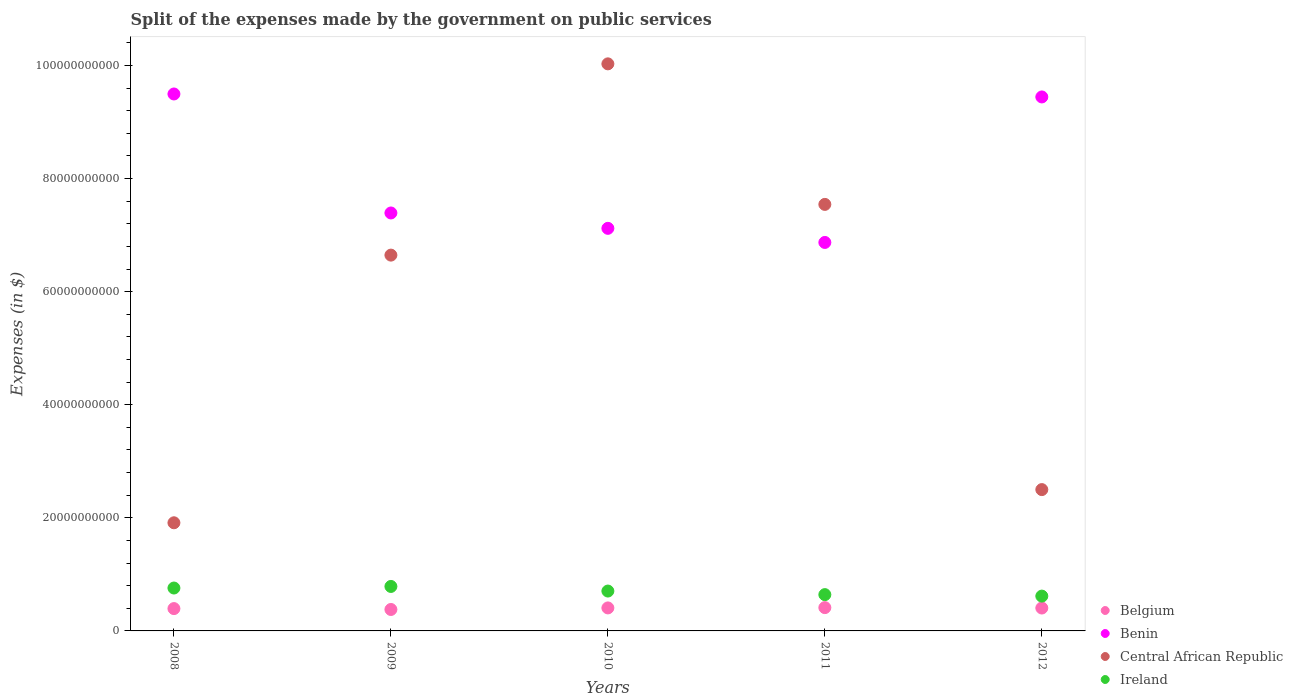Is the number of dotlines equal to the number of legend labels?
Provide a succinct answer. Yes. What is the expenses made by the government on public services in Central African Republic in 2011?
Offer a very short reply. 7.54e+1. Across all years, what is the maximum expenses made by the government on public services in Ireland?
Ensure brevity in your answer.  7.87e+09. Across all years, what is the minimum expenses made by the government on public services in Belgium?
Offer a very short reply. 3.79e+09. What is the total expenses made by the government on public services in Belgium in the graph?
Provide a succinct answer. 2.00e+1. What is the difference between the expenses made by the government on public services in Benin in 2009 and that in 2012?
Provide a short and direct response. -2.05e+1. What is the difference between the expenses made by the government on public services in Ireland in 2008 and the expenses made by the government on public services in Benin in 2010?
Make the answer very short. -6.36e+1. What is the average expenses made by the government on public services in Central African Republic per year?
Offer a very short reply. 5.73e+1. In the year 2011, what is the difference between the expenses made by the government on public services in Belgium and expenses made by the government on public services in Central African Republic?
Your answer should be compact. -7.13e+1. What is the ratio of the expenses made by the government on public services in Ireland in 2011 to that in 2012?
Ensure brevity in your answer.  1.04. Is the expenses made by the government on public services in Central African Republic in 2010 less than that in 2012?
Offer a terse response. No. What is the difference between the highest and the second highest expenses made by the government on public services in Ireland?
Provide a short and direct response. 2.79e+08. What is the difference between the highest and the lowest expenses made by the government on public services in Ireland?
Keep it short and to the point. 1.71e+09. In how many years, is the expenses made by the government on public services in Belgium greater than the average expenses made by the government on public services in Belgium taken over all years?
Ensure brevity in your answer.  3. Is the sum of the expenses made by the government on public services in Ireland in 2008 and 2011 greater than the maximum expenses made by the government on public services in Benin across all years?
Make the answer very short. No. Is it the case that in every year, the sum of the expenses made by the government on public services in Ireland and expenses made by the government on public services in Belgium  is greater than the sum of expenses made by the government on public services in Benin and expenses made by the government on public services in Central African Republic?
Give a very brief answer. No. Is it the case that in every year, the sum of the expenses made by the government on public services in Benin and expenses made by the government on public services in Ireland  is greater than the expenses made by the government on public services in Belgium?
Provide a short and direct response. Yes. How many dotlines are there?
Offer a very short reply. 4. What is the difference between two consecutive major ticks on the Y-axis?
Give a very brief answer. 2.00e+1. Are the values on the major ticks of Y-axis written in scientific E-notation?
Offer a very short reply. No. Does the graph contain grids?
Offer a very short reply. No. Where does the legend appear in the graph?
Keep it short and to the point. Bottom right. What is the title of the graph?
Offer a very short reply. Split of the expenses made by the government on public services. What is the label or title of the Y-axis?
Your response must be concise. Expenses (in $). What is the Expenses (in $) in Belgium in 2008?
Ensure brevity in your answer.  3.95e+09. What is the Expenses (in $) in Benin in 2008?
Offer a very short reply. 9.50e+1. What is the Expenses (in $) in Central African Republic in 2008?
Offer a very short reply. 1.91e+1. What is the Expenses (in $) of Ireland in 2008?
Your answer should be compact. 7.59e+09. What is the Expenses (in $) in Belgium in 2009?
Provide a succinct answer. 3.79e+09. What is the Expenses (in $) of Benin in 2009?
Ensure brevity in your answer.  7.39e+1. What is the Expenses (in $) in Central African Republic in 2009?
Provide a short and direct response. 6.65e+1. What is the Expenses (in $) of Ireland in 2009?
Ensure brevity in your answer.  7.87e+09. What is the Expenses (in $) of Belgium in 2010?
Your answer should be very brief. 4.07e+09. What is the Expenses (in $) of Benin in 2010?
Your response must be concise. 7.12e+1. What is the Expenses (in $) of Central African Republic in 2010?
Provide a short and direct response. 1.00e+11. What is the Expenses (in $) in Ireland in 2010?
Offer a terse response. 7.05e+09. What is the Expenses (in $) in Belgium in 2011?
Keep it short and to the point. 4.12e+09. What is the Expenses (in $) of Benin in 2011?
Ensure brevity in your answer.  6.87e+1. What is the Expenses (in $) in Central African Republic in 2011?
Your answer should be compact. 7.54e+1. What is the Expenses (in $) in Ireland in 2011?
Your answer should be very brief. 6.42e+09. What is the Expenses (in $) in Belgium in 2012?
Offer a very short reply. 4.05e+09. What is the Expenses (in $) of Benin in 2012?
Keep it short and to the point. 9.44e+1. What is the Expenses (in $) of Central African Republic in 2012?
Your answer should be very brief. 2.50e+1. What is the Expenses (in $) in Ireland in 2012?
Offer a very short reply. 6.16e+09. Across all years, what is the maximum Expenses (in $) in Belgium?
Provide a succinct answer. 4.12e+09. Across all years, what is the maximum Expenses (in $) of Benin?
Provide a short and direct response. 9.50e+1. Across all years, what is the maximum Expenses (in $) of Central African Republic?
Ensure brevity in your answer.  1.00e+11. Across all years, what is the maximum Expenses (in $) in Ireland?
Provide a succinct answer. 7.87e+09. Across all years, what is the minimum Expenses (in $) of Belgium?
Offer a terse response. 3.79e+09. Across all years, what is the minimum Expenses (in $) in Benin?
Your answer should be compact. 6.87e+1. Across all years, what is the minimum Expenses (in $) in Central African Republic?
Your response must be concise. 1.91e+1. Across all years, what is the minimum Expenses (in $) in Ireland?
Your answer should be compact. 6.16e+09. What is the total Expenses (in $) in Belgium in the graph?
Offer a very short reply. 2.00e+1. What is the total Expenses (in $) in Benin in the graph?
Offer a terse response. 4.03e+11. What is the total Expenses (in $) of Central African Republic in the graph?
Provide a succinct answer. 2.86e+11. What is the total Expenses (in $) in Ireland in the graph?
Offer a very short reply. 3.51e+1. What is the difference between the Expenses (in $) in Belgium in 2008 and that in 2009?
Provide a succinct answer. 1.58e+08. What is the difference between the Expenses (in $) of Benin in 2008 and that in 2009?
Provide a short and direct response. 2.10e+1. What is the difference between the Expenses (in $) in Central African Republic in 2008 and that in 2009?
Give a very brief answer. -4.73e+1. What is the difference between the Expenses (in $) of Ireland in 2008 and that in 2009?
Ensure brevity in your answer.  -2.79e+08. What is the difference between the Expenses (in $) in Belgium in 2008 and that in 2010?
Provide a short and direct response. -1.18e+08. What is the difference between the Expenses (in $) in Benin in 2008 and that in 2010?
Your answer should be compact. 2.38e+1. What is the difference between the Expenses (in $) in Central African Republic in 2008 and that in 2010?
Provide a short and direct response. -8.12e+1. What is the difference between the Expenses (in $) in Ireland in 2008 and that in 2010?
Ensure brevity in your answer.  5.35e+08. What is the difference between the Expenses (in $) of Belgium in 2008 and that in 2011?
Your answer should be compact. -1.72e+08. What is the difference between the Expenses (in $) of Benin in 2008 and that in 2011?
Ensure brevity in your answer.  2.63e+1. What is the difference between the Expenses (in $) of Central African Republic in 2008 and that in 2011?
Provide a short and direct response. -5.63e+1. What is the difference between the Expenses (in $) of Ireland in 2008 and that in 2011?
Ensure brevity in your answer.  1.17e+09. What is the difference between the Expenses (in $) in Belgium in 2008 and that in 2012?
Your answer should be compact. -9.98e+07. What is the difference between the Expenses (in $) of Benin in 2008 and that in 2012?
Offer a very short reply. 5.24e+08. What is the difference between the Expenses (in $) of Central African Republic in 2008 and that in 2012?
Offer a very short reply. -5.87e+09. What is the difference between the Expenses (in $) in Ireland in 2008 and that in 2012?
Offer a terse response. 1.43e+09. What is the difference between the Expenses (in $) of Belgium in 2009 and that in 2010?
Your answer should be very brief. -2.76e+08. What is the difference between the Expenses (in $) in Benin in 2009 and that in 2010?
Offer a very short reply. 2.72e+09. What is the difference between the Expenses (in $) of Central African Republic in 2009 and that in 2010?
Your answer should be very brief. -3.38e+1. What is the difference between the Expenses (in $) in Ireland in 2009 and that in 2010?
Provide a short and direct response. 8.15e+08. What is the difference between the Expenses (in $) in Belgium in 2009 and that in 2011?
Provide a succinct answer. -3.30e+08. What is the difference between the Expenses (in $) in Benin in 2009 and that in 2011?
Provide a succinct answer. 5.21e+09. What is the difference between the Expenses (in $) in Central African Republic in 2009 and that in 2011?
Offer a very short reply. -8.97e+09. What is the difference between the Expenses (in $) in Ireland in 2009 and that in 2011?
Make the answer very short. 1.45e+09. What is the difference between the Expenses (in $) in Belgium in 2009 and that in 2012?
Give a very brief answer. -2.58e+08. What is the difference between the Expenses (in $) of Benin in 2009 and that in 2012?
Make the answer very short. -2.05e+1. What is the difference between the Expenses (in $) of Central African Republic in 2009 and that in 2012?
Give a very brief answer. 4.15e+1. What is the difference between the Expenses (in $) of Ireland in 2009 and that in 2012?
Provide a succinct answer. 1.71e+09. What is the difference between the Expenses (in $) of Belgium in 2010 and that in 2011?
Provide a short and direct response. -5.37e+07. What is the difference between the Expenses (in $) of Benin in 2010 and that in 2011?
Your response must be concise. 2.49e+09. What is the difference between the Expenses (in $) of Central African Republic in 2010 and that in 2011?
Your answer should be compact. 2.49e+1. What is the difference between the Expenses (in $) of Ireland in 2010 and that in 2011?
Give a very brief answer. 6.31e+08. What is the difference between the Expenses (in $) of Belgium in 2010 and that in 2012?
Ensure brevity in your answer.  1.86e+07. What is the difference between the Expenses (in $) in Benin in 2010 and that in 2012?
Provide a short and direct response. -2.32e+1. What is the difference between the Expenses (in $) of Central African Republic in 2010 and that in 2012?
Offer a very short reply. 7.53e+1. What is the difference between the Expenses (in $) of Ireland in 2010 and that in 2012?
Provide a short and direct response. 8.94e+08. What is the difference between the Expenses (in $) in Belgium in 2011 and that in 2012?
Your answer should be compact. 7.23e+07. What is the difference between the Expenses (in $) in Benin in 2011 and that in 2012?
Make the answer very short. -2.57e+1. What is the difference between the Expenses (in $) in Central African Republic in 2011 and that in 2012?
Your answer should be very brief. 5.04e+1. What is the difference between the Expenses (in $) of Ireland in 2011 and that in 2012?
Your answer should be very brief. 2.63e+08. What is the difference between the Expenses (in $) of Belgium in 2008 and the Expenses (in $) of Benin in 2009?
Keep it short and to the point. -7.00e+1. What is the difference between the Expenses (in $) in Belgium in 2008 and the Expenses (in $) in Central African Republic in 2009?
Give a very brief answer. -6.25e+1. What is the difference between the Expenses (in $) of Belgium in 2008 and the Expenses (in $) of Ireland in 2009?
Give a very brief answer. -3.92e+09. What is the difference between the Expenses (in $) in Benin in 2008 and the Expenses (in $) in Central African Republic in 2009?
Give a very brief answer. 2.85e+1. What is the difference between the Expenses (in $) of Benin in 2008 and the Expenses (in $) of Ireland in 2009?
Your response must be concise. 8.71e+1. What is the difference between the Expenses (in $) of Central African Republic in 2008 and the Expenses (in $) of Ireland in 2009?
Your response must be concise. 1.13e+1. What is the difference between the Expenses (in $) in Belgium in 2008 and the Expenses (in $) in Benin in 2010?
Give a very brief answer. -6.72e+1. What is the difference between the Expenses (in $) in Belgium in 2008 and the Expenses (in $) in Central African Republic in 2010?
Your answer should be very brief. -9.63e+1. What is the difference between the Expenses (in $) of Belgium in 2008 and the Expenses (in $) of Ireland in 2010?
Give a very brief answer. -3.10e+09. What is the difference between the Expenses (in $) in Benin in 2008 and the Expenses (in $) in Central African Republic in 2010?
Give a very brief answer. -5.33e+09. What is the difference between the Expenses (in $) of Benin in 2008 and the Expenses (in $) of Ireland in 2010?
Offer a terse response. 8.79e+1. What is the difference between the Expenses (in $) of Central African Republic in 2008 and the Expenses (in $) of Ireland in 2010?
Give a very brief answer. 1.21e+1. What is the difference between the Expenses (in $) in Belgium in 2008 and the Expenses (in $) in Benin in 2011?
Your response must be concise. -6.48e+1. What is the difference between the Expenses (in $) in Belgium in 2008 and the Expenses (in $) in Central African Republic in 2011?
Give a very brief answer. -7.15e+1. What is the difference between the Expenses (in $) in Belgium in 2008 and the Expenses (in $) in Ireland in 2011?
Provide a short and direct response. -2.47e+09. What is the difference between the Expenses (in $) of Benin in 2008 and the Expenses (in $) of Central African Republic in 2011?
Offer a terse response. 1.95e+1. What is the difference between the Expenses (in $) of Benin in 2008 and the Expenses (in $) of Ireland in 2011?
Provide a succinct answer. 8.85e+1. What is the difference between the Expenses (in $) of Central African Republic in 2008 and the Expenses (in $) of Ireland in 2011?
Your answer should be compact. 1.27e+1. What is the difference between the Expenses (in $) in Belgium in 2008 and the Expenses (in $) in Benin in 2012?
Your answer should be very brief. -9.05e+1. What is the difference between the Expenses (in $) of Belgium in 2008 and the Expenses (in $) of Central African Republic in 2012?
Give a very brief answer. -2.10e+1. What is the difference between the Expenses (in $) of Belgium in 2008 and the Expenses (in $) of Ireland in 2012?
Your answer should be compact. -2.21e+09. What is the difference between the Expenses (in $) in Benin in 2008 and the Expenses (in $) in Central African Republic in 2012?
Offer a very short reply. 7.00e+1. What is the difference between the Expenses (in $) in Benin in 2008 and the Expenses (in $) in Ireland in 2012?
Ensure brevity in your answer.  8.88e+1. What is the difference between the Expenses (in $) of Central African Republic in 2008 and the Expenses (in $) of Ireland in 2012?
Offer a terse response. 1.30e+1. What is the difference between the Expenses (in $) in Belgium in 2009 and the Expenses (in $) in Benin in 2010?
Make the answer very short. -6.74e+1. What is the difference between the Expenses (in $) in Belgium in 2009 and the Expenses (in $) in Central African Republic in 2010?
Make the answer very short. -9.65e+1. What is the difference between the Expenses (in $) in Belgium in 2009 and the Expenses (in $) in Ireland in 2010?
Your answer should be compact. -3.26e+09. What is the difference between the Expenses (in $) of Benin in 2009 and the Expenses (in $) of Central African Republic in 2010?
Offer a very short reply. -2.64e+1. What is the difference between the Expenses (in $) of Benin in 2009 and the Expenses (in $) of Ireland in 2010?
Make the answer very short. 6.69e+1. What is the difference between the Expenses (in $) in Central African Republic in 2009 and the Expenses (in $) in Ireland in 2010?
Ensure brevity in your answer.  5.94e+1. What is the difference between the Expenses (in $) in Belgium in 2009 and the Expenses (in $) in Benin in 2011?
Your answer should be compact. -6.49e+1. What is the difference between the Expenses (in $) in Belgium in 2009 and the Expenses (in $) in Central African Republic in 2011?
Provide a succinct answer. -7.16e+1. What is the difference between the Expenses (in $) of Belgium in 2009 and the Expenses (in $) of Ireland in 2011?
Offer a very short reply. -2.63e+09. What is the difference between the Expenses (in $) in Benin in 2009 and the Expenses (in $) in Central African Republic in 2011?
Your response must be concise. -1.52e+09. What is the difference between the Expenses (in $) in Benin in 2009 and the Expenses (in $) in Ireland in 2011?
Provide a short and direct response. 6.75e+1. What is the difference between the Expenses (in $) in Central African Republic in 2009 and the Expenses (in $) in Ireland in 2011?
Offer a very short reply. 6.00e+1. What is the difference between the Expenses (in $) of Belgium in 2009 and the Expenses (in $) of Benin in 2012?
Make the answer very short. -9.06e+1. What is the difference between the Expenses (in $) of Belgium in 2009 and the Expenses (in $) of Central African Republic in 2012?
Your answer should be compact. -2.12e+1. What is the difference between the Expenses (in $) in Belgium in 2009 and the Expenses (in $) in Ireland in 2012?
Your response must be concise. -2.36e+09. What is the difference between the Expenses (in $) of Benin in 2009 and the Expenses (in $) of Central African Republic in 2012?
Offer a very short reply. 4.89e+1. What is the difference between the Expenses (in $) in Benin in 2009 and the Expenses (in $) in Ireland in 2012?
Your response must be concise. 6.78e+1. What is the difference between the Expenses (in $) in Central African Republic in 2009 and the Expenses (in $) in Ireland in 2012?
Offer a terse response. 6.03e+1. What is the difference between the Expenses (in $) in Belgium in 2010 and the Expenses (in $) in Benin in 2011?
Offer a very short reply. -6.46e+1. What is the difference between the Expenses (in $) in Belgium in 2010 and the Expenses (in $) in Central African Republic in 2011?
Keep it short and to the point. -7.14e+1. What is the difference between the Expenses (in $) of Belgium in 2010 and the Expenses (in $) of Ireland in 2011?
Offer a terse response. -2.35e+09. What is the difference between the Expenses (in $) in Benin in 2010 and the Expenses (in $) in Central African Republic in 2011?
Provide a succinct answer. -4.24e+09. What is the difference between the Expenses (in $) in Benin in 2010 and the Expenses (in $) in Ireland in 2011?
Offer a very short reply. 6.48e+1. What is the difference between the Expenses (in $) of Central African Republic in 2010 and the Expenses (in $) of Ireland in 2011?
Offer a terse response. 9.39e+1. What is the difference between the Expenses (in $) of Belgium in 2010 and the Expenses (in $) of Benin in 2012?
Provide a succinct answer. -9.04e+1. What is the difference between the Expenses (in $) in Belgium in 2010 and the Expenses (in $) in Central African Republic in 2012?
Your answer should be compact. -2.09e+1. What is the difference between the Expenses (in $) in Belgium in 2010 and the Expenses (in $) in Ireland in 2012?
Offer a terse response. -2.09e+09. What is the difference between the Expenses (in $) of Benin in 2010 and the Expenses (in $) of Central African Republic in 2012?
Your response must be concise. 4.62e+1. What is the difference between the Expenses (in $) in Benin in 2010 and the Expenses (in $) in Ireland in 2012?
Your answer should be very brief. 6.50e+1. What is the difference between the Expenses (in $) in Central African Republic in 2010 and the Expenses (in $) in Ireland in 2012?
Your answer should be compact. 9.41e+1. What is the difference between the Expenses (in $) in Belgium in 2011 and the Expenses (in $) in Benin in 2012?
Your answer should be very brief. -9.03e+1. What is the difference between the Expenses (in $) in Belgium in 2011 and the Expenses (in $) in Central African Republic in 2012?
Provide a short and direct response. -2.09e+1. What is the difference between the Expenses (in $) in Belgium in 2011 and the Expenses (in $) in Ireland in 2012?
Offer a very short reply. -2.04e+09. What is the difference between the Expenses (in $) in Benin in 2011 and the Expenses (in $) in Central African Republic in 2012?
Offer a terse response. 4.37e+1. What is the difference between the Expenses (in $) of Benin in 2011 and the Expenses (in $) of Ireland in 2012?
Your answer should be compact. 6.25e+1. What is the difference between the Expenses (in $) of Central African Republic in 2011 and the Expenses (in $) of Ireland in 2012?
Your answer should be compact. 6.93e+1. What is the average Expenses (in $) of Belgium per year?
Ensure brevity in your answer.  4.00e+09. What is the average Expenses (in $) in Benin per year?
Keep it short and to the point. 8.06e+1. What is the average Expenses (in $) in Central African Republic per year?
Offer a very short reply. 5.73e+1. What is the average Expenses (in $) in Ireland per year?
Provide a succinct answer. 7.02e+09. In the year 2008, what is the difference between the Expenses (in $) in Belgium and Expenses (in $) in Benin?
Give a very brief answer. -9.10e+1. In the year 2008, what is the difference between the Expenses (in $) in Belgium and Expenses (in $) in Central African Republic?
Keep it short and to the point. -1.52e+1. In the year 2008, what is the difference between the Expenses (in $) in Belgium and Expenses (in $) in Ireland?
Make the answer very short. -3.64e+09. In the year 2008, what is the difference between the Expenses (in $) in Benin and Expenses (in $) in Central African Republic?
Offer a terse response. 7.58e+1. In the year 2008, what is the difference between the Expenses (in $) in Benin and Expenses (in $) in Ireland?
Offer a very short reply. 8.74e+1. In the year 2008, what is the difference between the Expenses (in $) of Central African Republic and Expenses (in $) of Ireland?
Offer a terse response. 1.15e+1. In the year 2009, what is the difference between the Expenses (in $) in Belgium and Expenses (in $) in Benin?
Keep it short and to the point. -7.01e+1. In the year 2009, what is the difference between the Expenses (in $) of Belgium and Expenses (in $) of Central African Republic?
Your response must be concise. -6.27e+1. In the year 2009, what is the difference between the Expenses (in $) of Belgium and Expenses (in $) of Ireland?
Your answer should be compact. -4.07e+09. In the year 2009, what is the difference between the Expenses (in $) in Benin and Expenses (in $) in Central African Republic?
Keep it short and to the point. 7.45e+09. In the year 2009, what is the difference between the Expenses (in $) of Benin and Expenses (in $) of Ireland?
Make the answer very short. 6.61e+1. In the year 2009, what is the difference between the Expenses (in $) of Central African Republic and Expenses (in $) of Ireland?
Make the answer very short. 5.86e+1. In the year 2010, what is the difference between the Expenses (in $) in Belgium and Expenses (in $) in Benin?
Provide a short and direct response. -6.71e+1. In the year 2010, what is the difference between the Expenses (in $) in Belgium and Expenses (in $) in Central African Republic?
Keep it short and to the point. -9.62e+1. In the year 2010, what is the difference between the Expenses (in $) in Belgium and Expenses (in $) in Ireland?
Make the answer very short. -2.98e+09. In the year 2010, what is the difference between the Expenses (in $) of Benin and Expenses (in $) of Central African Republic?
Provide a short and direct response. -2.91e+1. In the year 2010, what is the difference between the Expenses (in $) of Benin and Expenses (in $) of Ireland?
Ensure brevity in your answer.  6.41e+1. In the year 2010, what is the difference between the Expenses (in $) in Central African Republic and Expenses (in $) in Ireland?
Keep it short and to the point. 9.32e+1. In the year 2011, what is the difference between the Expenses (in $) of Belgium and Expenses (in $) of Benin?
Make the answer very short. -6.46e+1. In the year 2011, what is the difference between the Expenses (in $) in Belgium and Expenses (in $) in Central African Republic?
Provide a short and direct response. -7.13e+1. In the year 2011, what is the difference between the Expenses (in $) in Belgium and Expenses (in $) in Ireland?
Your response must be concise. -2.30e+09. In the year 2011, what is the difference between the Expenses (in $) in Benin and Expenses (in $) in Central African Republic?
Your response must be concise. -6.73e+09. In the year 2011, what is the difference between the Expenses (in $) of Benin and Expenses (in $) of Ireland?
Your response must be concise. 6.23e+1. In the year 2011, what is the difference between the Expenses (in $) of Central African Republic and Expenses (in $) of Ireland?
Your answer should be compact. 6.90e+1. In the year 2012, what is the difference between the Expenses (in $) in Belgium and Expenses (in $) in Benin?
Make the answer very short. -9.04e+1. In the year 2012, what is the difference between the Expenses (in $) in Belgium and Expenses (in $) in Central African Republic?
Offer a terse response. -2.09e+1. In the year 2012, what is the difference between the Expenses (in $) of Belgium and Expenses (in $) of Ireland?
Provide a short and direct response. -2.11e+09. In the year 2012, what is the difference between the Expenses (in $) in Benin and Expenses (in $) in Central African Republic?
Make the answer very short. 6.94e+1. In the year 2012, what is the difference between the Expenses (in $) of Benin and Expenses (in $) of Ireland?
Provide a succinct answer. 8.83e+1. In the year 2012, what is the difference between the Expenses (in $) of Central African Republic and Expenses (in $) of Ireland?
Offer a terse response. 1.88e+1. What is the ratio of the Expenses (in $) in Belgium in 2008 to that in 2009?
Make the answer very short. 1.04. What is the ratio of the Expenses (in $) in Benin in 2008 to that in 2009?
Your answer should be compact. 1.28. What is the ratio of the Expenses (in $) in Central African Republic in 2008 to that in 2009?
Provide a short and direct response. 0.29. What is the ratio of the Expenses (in $) of Ireland in 2008 to that in 2009?
Your response must be concise. 0.96. What is the ratio of the Expenses (in $) of Belgium in 2008 to that in 2010?
Offer a terse response. 0.97. What is the ratio of the Expenses (in $) in Benin in 2008 to that in 2010?
Your answer should be compact. 1.33. What is the ratio of the Expenses (in $) in Central African Republic in 2008 to that in 2010?
Your answer should be compact. 0.19. What is the ratio of the Expenses (in $) of Ireland in 2008 to that in 2010?
Your answer should be very brief. 1.08. What is the ratio of the Expenses (in $) in Belgium in 2008 to that in 2011?
Your response must be concise. 0.96. What is the ratio of the Expenses (in $) of Benin in 2008 to that in 2011?
Make the answer very short. 1.38. What is the ratio of the Expenses (in $) of Central African Republic in 2008 to that in 2011?
Your answer should be very brief. 0.25. What is the ratio of the Expenses (in $) in Ireland in 2008 to that in 2011?
Your answer should be very brief. 1.18. What is the ratio of the Expenses (in $) of Belgium in 2008 to that in 2012?
Make the answer very short. 0.98. What is the ratio of the Expenses (in $) in Central African Republic in 2008 to that in 2012?
Ensure brevity in your answer.  0.77. What is the ratio of the Expenses (in $) in Ireland in 2008 to that in 2012?
Your answer should be very brief. 1.23. What is the ratio of the Expenses (in $) of Belgium in 2009 to that in 2010?
Provide a short and direct response. 0.93. What is the ratio of the Expenses (in $) of Benin in 2009 to that in 2010?
Make the answer very short. 1.04. What is the ratio of the Expenses (in $) in Central African Republic in 2009 to that in 2010?
Your answer should be very brief. 0.66. What is the ratio of the Expenses (in $) of Ireland in 2009 to that in 2010?
Give a very brief answer. 1.12. What is the ratio of the Expenses (in $) in Benin in 2009 to that in 2011?
Ensure brevity in your answer.  1.08. What is the ratio of the Expenses (in $) of Central African Republic in 2009 to that in 2011?
Offer a very short reply. 0.88. What is the ratio of the Expenses (in $) in Ireland in 2009 to that in 2011?
Your response must be concise. 1.23. What is the ratio of the Expenses (in $) of Belgium in 2009 to that in 2012?
Ensure brevity in your answer.  0.94. What is the ratio of the Expenses (in $) of Benin in 2009 to that in 2012?
Provide a short and direct response. 0.78. What is the ratio of the Expenses (in $) of Central African Republic in 2009 to that in 2012?
Give a very brief answer. 2.66. What is the ratio of the Expenses (in $) in Ireland in 2009 to that in 2012?
Your answer should be compact. 1.28. What is the ratio of the Expenses (in $) in Belgium in 2010 to that in 2011?
Provide a short and direct response. 0.99. What is the ratio of the Expenses (in $) in Benin in 2010 to that in 2011?
Make the answer very short. 1.04. What is the ratio of the Expenses (in $) in Central African Republic in 2010 to that in 2011?
Keep it short and to the point. 1.33. What is the ratio of the Expenses (in $) in Ireland in 2010 to that in 2011?
Offer a very short reply. 1.1. What is the ratio of the Expenses (in $) in Belgium in 2010 to that in 2012?
Provide a short and direct response. 1. What is the ratio of the Expenses (in $) of Benin in 2010 to that in 2012?
Your answer should be very brief. 0.75. What is the ratio of the Expenses (in $) of Central African Republic in 2010 to that in 2012?
Your response must be concise. 4.01. What is the ratio of the Expenses (in $) in Ireland in 2010 to that in 2012?
Give a very brief answer. 1.15. What is the ratio of the Expenses (in $) in Belgium in 2011 to that in 2012?
Give a very brief answer. 1.02. What is the ratio of the Expenses (in $) of Benin in 2011 to that in 2012?
Your answer should be compact. 0.73. What is the ratio of the Expenses (in $) of Central African Republic in 2011 to that in 2012?
Your answer should be very brief. 3.02. What is the ratio of the Expenses (in $) in Ireland in 2011 to that in 2012?
Ensure brevity in your answer.  1.04. What is the difference between the highest and the second highest Expenses (in $) in Belgium?
Offer a terse response. 5.37e+07. What is the difference between the highest and the second highest Expenses (in $) of Benin?
Keep it short and to the point. 5.24e+08. What is the difference between the highest and the second highest Expenses (in $) in Central African Republic?
Ensure brevity in your answer.  2.49e+1. What is the difference between the highest and the second highest Expenses (in $) of Ireland?
Make the answer very short. 2.79e+08. What is the difference between the highest and the lowest Expenses (in $) in Belgium?
Provide a succinct answer. 3.30e+08. What is the difference between the highest and the lowest Expenses (in $) of Benin?
Offer a terse response. 2.63e+1. What is the difference between the highest and the lowest Expenses (in $) of Central African Republic?
Your response must be concise. 8.12e+1. What is the difference between the highest and the lowest Expenses (in $) of Ireland?
Your response must be concise. 1.71e+09. 